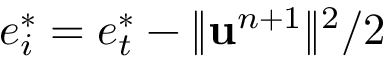Convert formula to latex. <formula><loc_0><loc_0><loc_500><loc_500>e _ { i } ^ { * } = e _ { t } ^ { * } - \| u ^ { n + 1 } \| ^ { 2 } / 2</formula> 